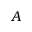<formula> <loc_0><loc_0><loc_500><loc_500>A</formula> 